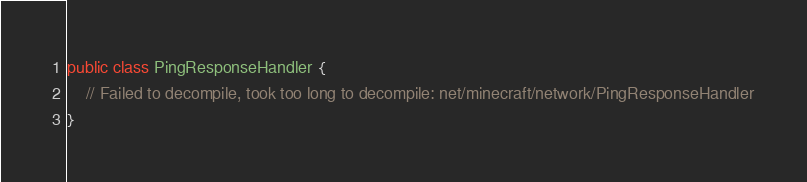<code> <loc_0><loc_0><loc_500><loc_500><_Java_>public class PingResponseHandler {
	// Failed to decompile, took too long to decompile: net/minecraft/network/PingResponseHandler
}</code> 